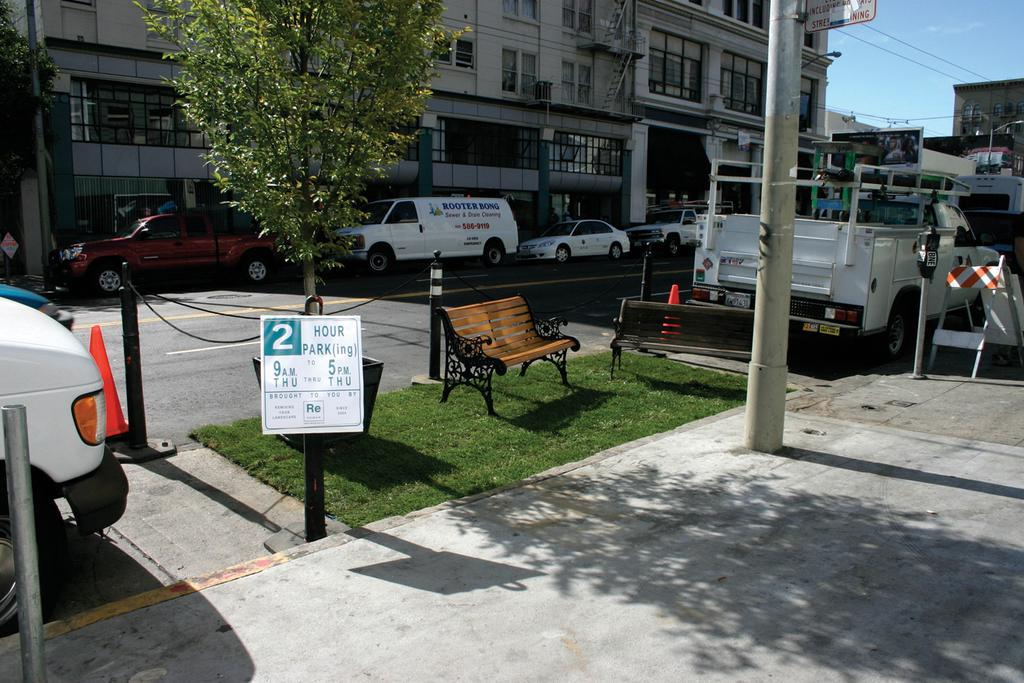What type of seating is visible in the image? There are benches in the image. What type of vehicles can be seen in the image? There are cars in the image. What type of vegetation is present in the image? There are trees in the image. What type of structure is visible in the image? There is a building in the image. What type of barrier is present in the image? There is a road blocker in the image. What type of vertical structure is present in the image? There is a pole in the image. What type of joke is being told by the mouth in the image? There is no mouth present in the image, and therefore no joke can be observed. Is there any water visible in the image? There is no mention of water in the provided facts, so we cannot determine if water is present in the image. 